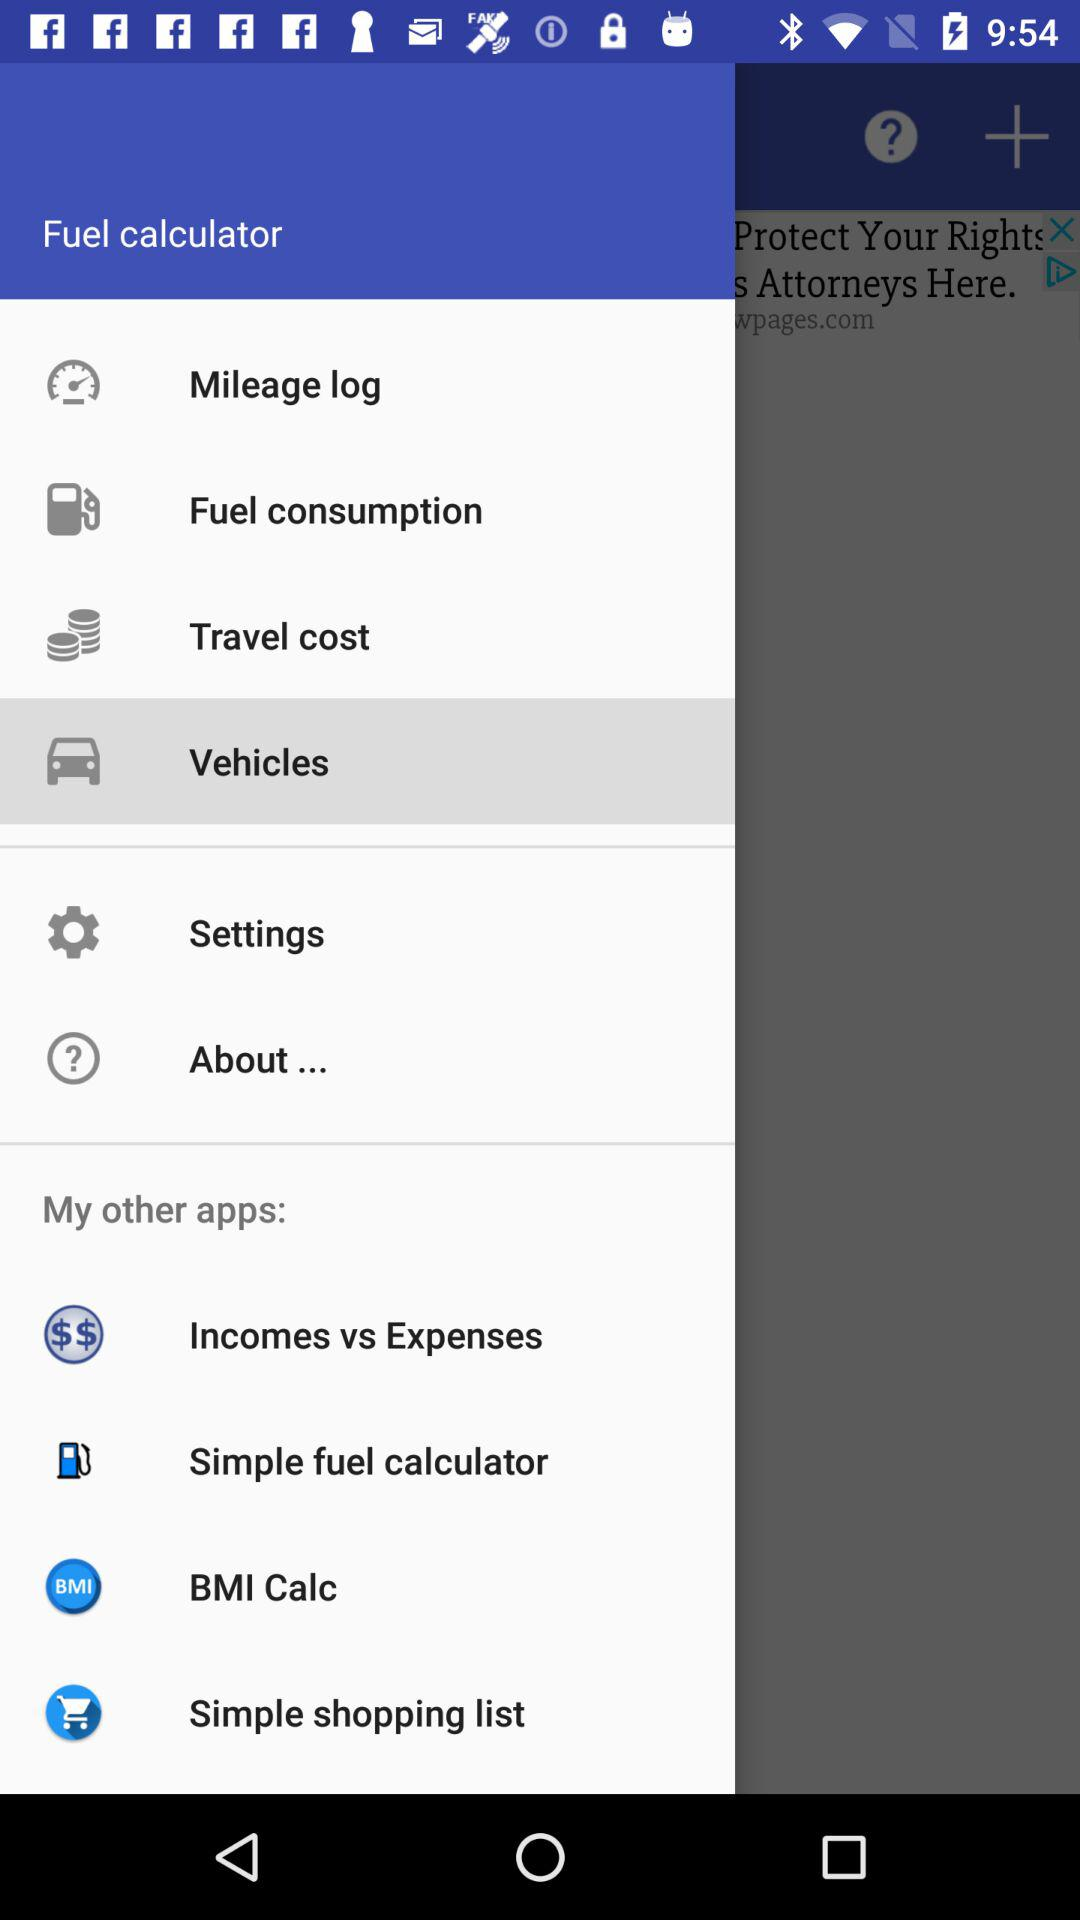How much fuel was consumed?
When the provided information is insufficient, respond with <no answer>. <no answer> 